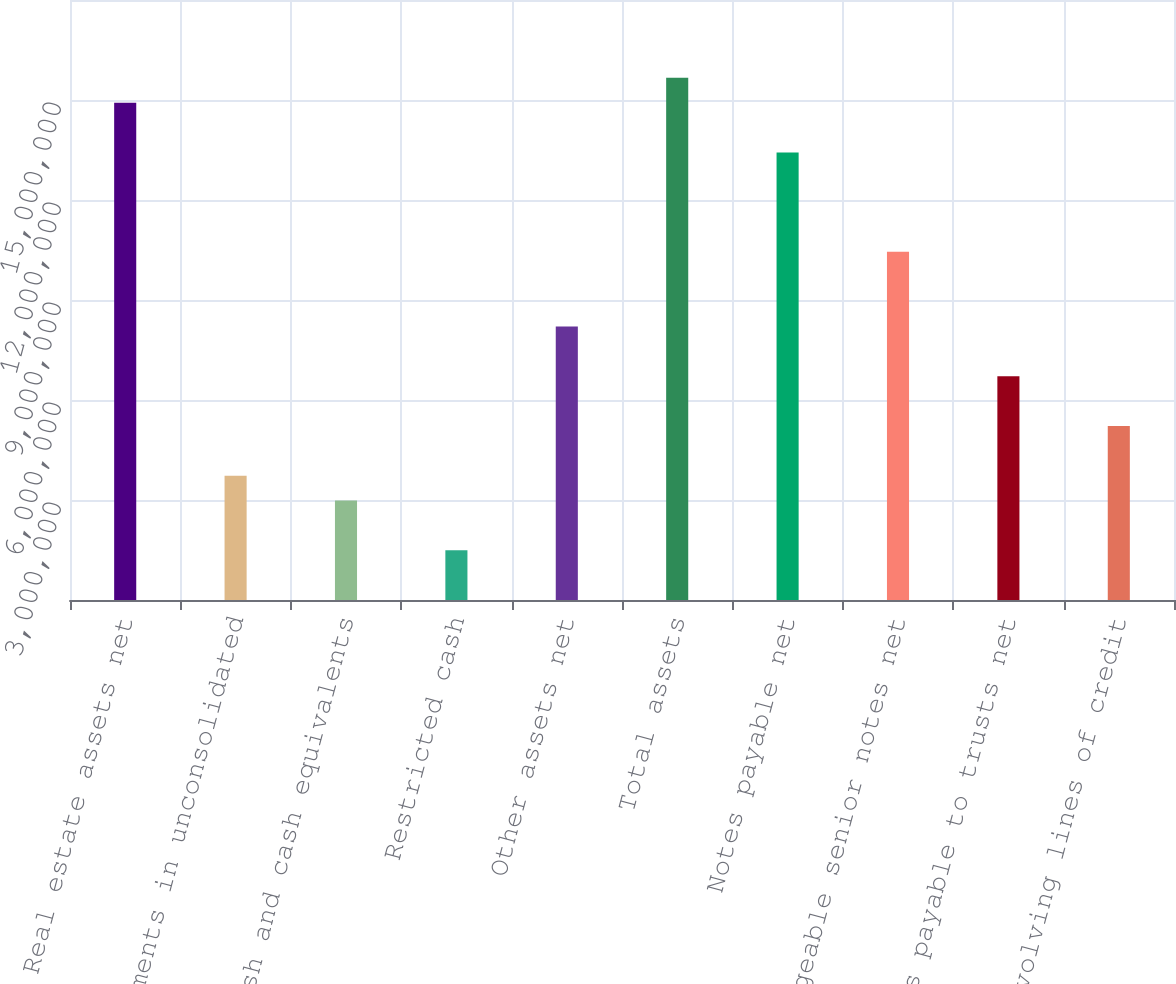Convert chart. <chart><loc_0><loc_0><loc_500><loc_500><bar_chart><fcel>Real estate assets net<fcel>Investments in unconsolidated<fcel>Cash and cash equivalents<fcel>Restricted cash<fcel>Other assets net<fcel>Total assets<fcel>Notes payable net<fcel>Exchangeable senior notes net<fcel>Notes payable to trusts net<fcel>Revolving lines of credit<nl><fcel>1.49206e+07<fcel>3.73111e+06<fcel>2.98514e+06<fcel>1.4932e+06<fcel>8.20692e+06<fcel>1.56666e+07<fcel>1.34287e+07<fcel>1.04448e+07<fcel>6.71498e+06<fcel>5.22305e+06<nl></chart> 